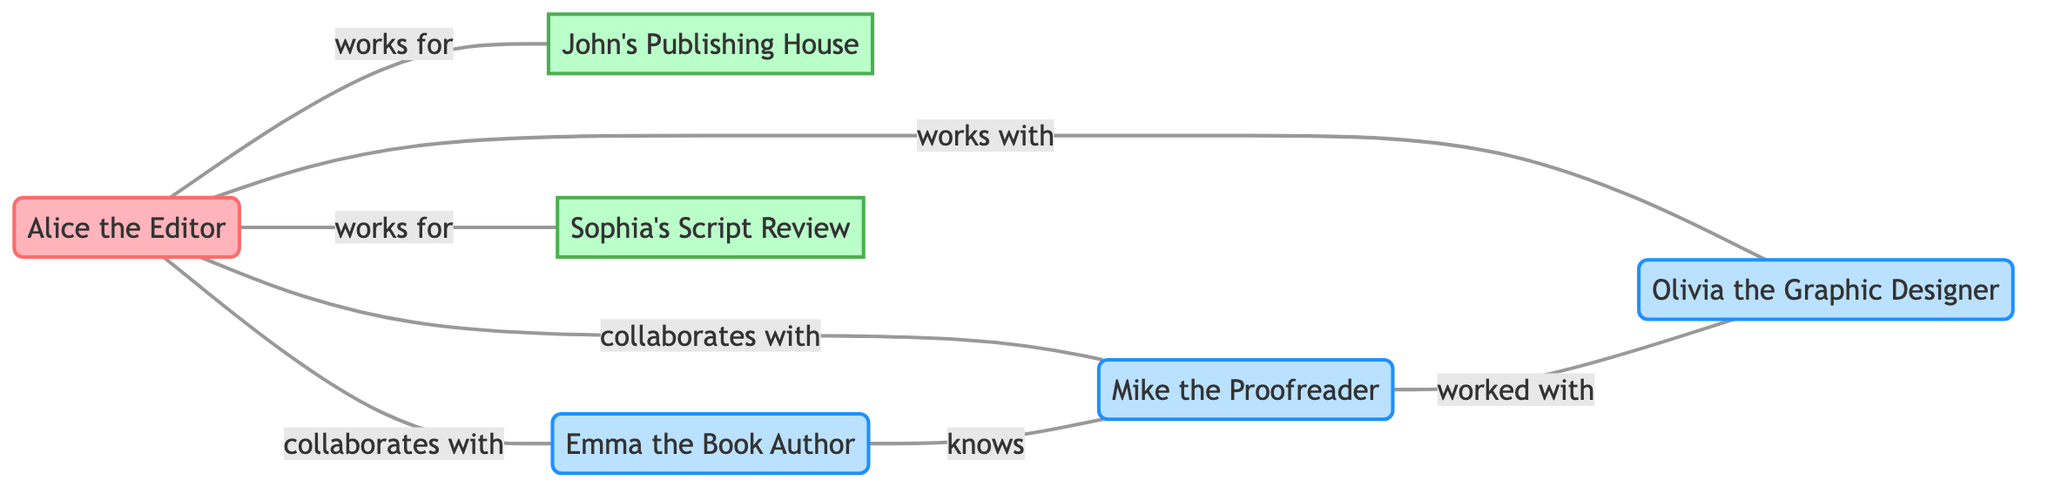What is the total number of nodes in the diagram? To find the total number of nodes, count the individual nodes listed, which are Alice the Editor, John's Publishing House, Emma the Book Author, Sophia's Script Review, Mike the Proofreader, and Olivia the Graphic Designer. This gives a total of six nodes.
Answer: 6 Who does Alice the Editor collaborate with? The diagram indicates that Alice the Editor collaborates with Emma the Book Author and Mike the Proofreader. Therefore, these two are the individuals Alice collaborates with.
Answer: Emma the Book Author, Mike the Proofreader How many clients does Alice the Editor work for? Alice the Editor is connected to two clients in the diagram, which are John's Publishing House and Sophia's Script Review. Thus, the number of clients is two.
Answer: 2 What relationship exists between Emma the Book Author and Mike the Proofreader? The diagram shows that Emma the Book Author knows Mike the Proofreader, indicating a relationship of acquaintance or familiarity between them.
Answer: knows Which professional connection has worked with Mike the Proofreader? According to the diagram, Olivia the Graphic Designer is the professional connection that has worked with Mike the Proofreader.
Answer: Olivia the Graphic Designer Is there a direct relationship between Alice the Editor and Olivia the Graphic Designer? The diagram indicates that Alice the Editor works with Olivia the Graphic Designer. This means there is a direct relationship, defined as working together.
Answer: works with How many unique relationships are shown in the diagram? To determine the number of unique relationships, count each edge in the diagram, which represent the relationships. There are a total of six unique relationships shown.
Answer: 6 What type of connection is represented between John's Publishing House and Alice the Editor? The diagram specifies the relationship between John's Publishing House and Alice the Editor as "works for," indicating a client-editor relationship.
Answer: works for 